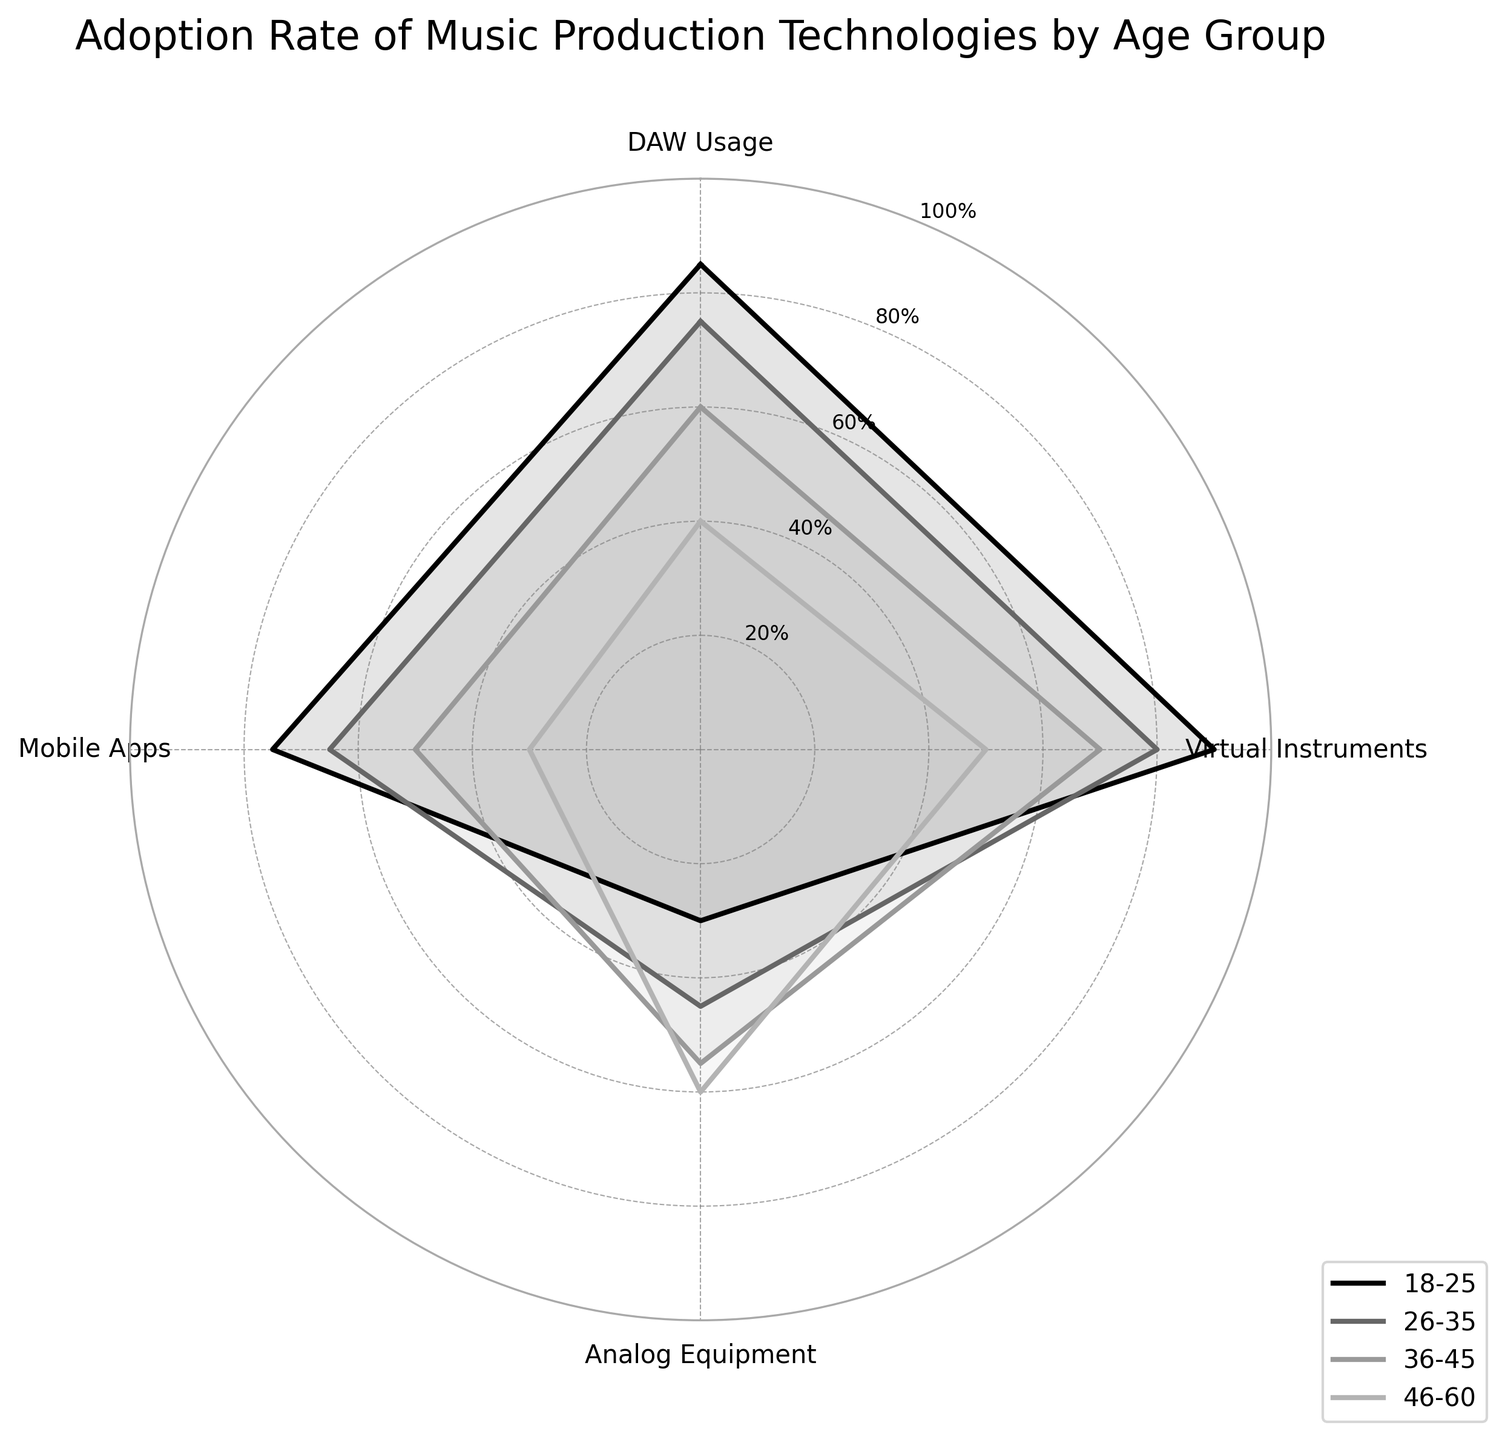Which age group has the highest adoption rate for Virtual Instruments? By looking at the radar chart, the group with the highest value will have the largest area covered for Virtual Instruments. The 18-25 age group has the highest adoption rate for Virtual Instruments at 90%.
Answer: 18-25 Which technology shows a steady decrease in adoption rates across age groups? Inspecting the radar chart, we observe that DAW Usage shows a continuous decline from the 18-25 age group to the 46-60 age group as the values go from 85% to 40%.
Answer: DAW Usage What is the average adoption rate for Analog Equipment by age groups? The values for Analog Equipment adoption rates are 30%, 45%, 55%, and 60% for the four age groups. Summing these values: 30 + 45 + 55 + 60 = 190. The average is then 190 / 4.
Answer: 47.5 Between the 18-25 and 26-35 age groups, which technology has the closest adoption rates? We compare the values for DAW Usage, Virtual Instruments, Analog Equipment, and Mobile Apps between these two age groups. Mobile Apps have 75% and 65%, respectively, which are the closest.
Answer: Mobile Apps Which age group has the lowest adoption rate for Mobile Apps? From the radar chart, the smallest value for Mobile Apps is found in the 46-60 age group, which has 30%.
Answer: 46-60 Which age group has the most balanced adoption rates across all technologies? By reviewing the radar chart, we look for the age group with the most even distribution across DAW Usage, Virtual Instruments, Analog Equipment, and Mobile Apps. The 26-35 age group shows the most balanced adoption rates without dramatically high or low values.
Answer: 26-35 What is the difference in adoption rate for DAW Usage between the youngest and oldest age groups? By subtracting the DAW Usage rate of the 46-60 age group (40%) from that of the 18-25 age group (85%), we get 85 - 40.
Answer: 45 How does the usage of Analog Equipment compare between the 36-45 and 46-60 age groups? Looking at the radar chart, Analog Equipment adoption is 55% for the 36-45 age group and 60% for the 46-60 age group. Therefore, Analog Equipment usage is greater in the 46-60 age group.
Answer: 46-60 What pattern can you see in the adoption rate of Mobile Apps across the age groups? Examining the radar chart, the adoption rate for Mobile Apps decreases as the age group increases, starting from 75% (18-25) down to 30% (46-60).
Answer: Decreases with age 